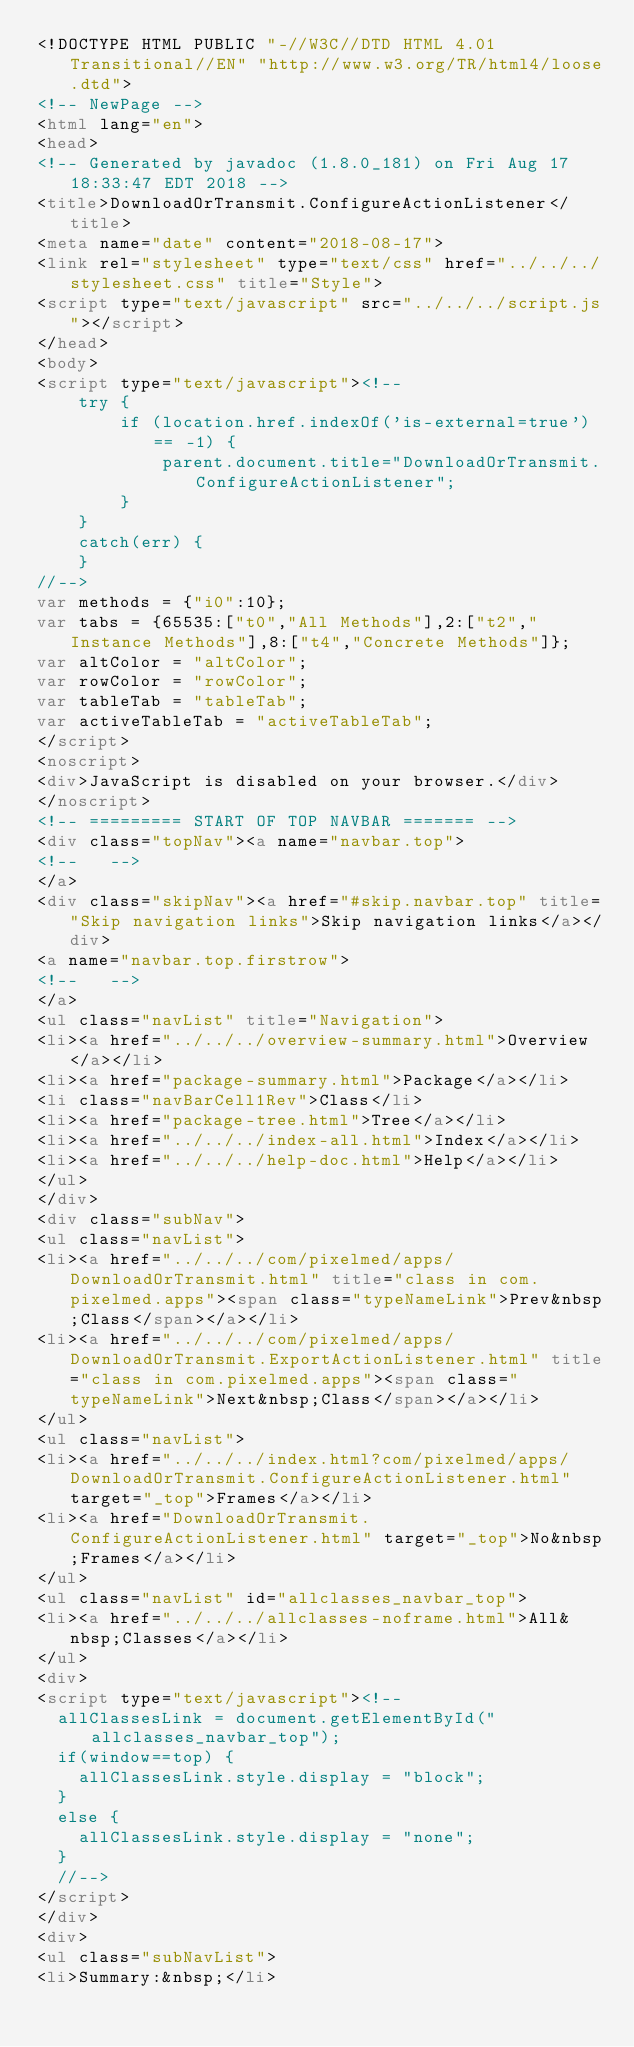<code> <loc_0><loc_0><loc_500><loc_500><_HTML_><!DOCTYPE HTML PUBLIC "-//W3C//DTD HTML 4.01 Transitional//EN" "http://www.w3.org/TR/html4/loose.dtd">
<!-- NewPage -->
<html lang="en">
<head>
<!-- Generated by javadoc (1.8.0_181) on Fri Aug 17 18:33:47 EDT 2018 -->
<title>DownloadOrTransmit.ConfigureActionListener</title>
<meta name="date" content="2018-08-17">
<link rel="stylesheet" type="text/css" href="../../../stylesheet.css" title="Style">
<script type="text/javascript" src="../../../script.js"></script>
</head>
<body>
<script type="text/javascript"><!--
    try {
        if (location.href.indexOf('is-external=true') == -1) {
            parent.document.title="DownloadOrTransmit.ConfigureActionListener";
        }
    }
    catch(err) {
    }
//-->
var methods = {"i0":10};
var tabs = {65535:["t0","All Methods"],2:["t2","Instance Methods"],8:["t4","Concrete Methods"]};
var altColor = "altColor";
var rowColor = "rowColor";
var tableTab = "tableTab";
var activeTableTab = "activeTableTab";
</script>
<noscript>
<div>JavaScript is disabled on your browser.</div>
</noscript>
<!-- ========= START OF TOP NAVBAR ======= -->
<div class="topNav"><a name="navbar.top">
<!--   -->
</a>
<div class="skipNav"><a href="#skip.navbar.top" title="Skip navigation links">Skip navigation links</a></div>
<a name="navbar.top.firstrow">
<!--   -->
</a>
<ul class="navList" title="Navigation">
<li><a href="../../../overview-summary.html">Overview</a></li>
<li><a href="package-summary.html">Package</a></li>
<li class="navBarCell1Rev">Class</li>
<li><a href="package-tree.html">Tree</a></li>
<li><a href="../../../index-all.html">Index</a></li>
<li><a href="../../../help-doc.html">Help</a></li>
</ul>
</div>
<div class="subNav">
<ul class="navList">
<li><a href="../../../com/pixelmed/apps/DownloadOrTransmit.html" title="class in com.pixelmed.apps"><span class="typeNameLink">Prev&nbsp;Class</span></a></li>
<li><a href="../../../com/pixelmed/apps/DownloadOrTransmit.ExportActionListener.html" title="class in com.pixelmed.apps"><span class="typeNameLink">Next&nbsp;Class</span></a></li>
</ul>
<ul class="navList">
<li><a href="../../../index.html?com/pixelmed/apps/DownloadOrTransmit.ConfigureActionListener.html" target="_top">Frames</a></li>
<li><a href="DownloadOrTransmit.ConfigureActionListener.html" target="_top">No&nbsp;Frames</a></li>
</ul>
<ul class="navList" id="allclasses_navbar_top">
<li><a href="../../../allclasses-noframe.html">All&nbsp;Classes</a></li>
</ul>
<div>
<script type="text/javascript"><!--
  allClassesLink = document.getElementById("allclasses_navbar_top");
  if(window==top) {
    allClassesLink.style.display = "block";
  }
  else {
    allClassesLink.style.display = "none";
  }
  //-->
</script>
</div>
<div>
<ul class="subNavList">
<li>Summary:&nbsp;</li></code> 